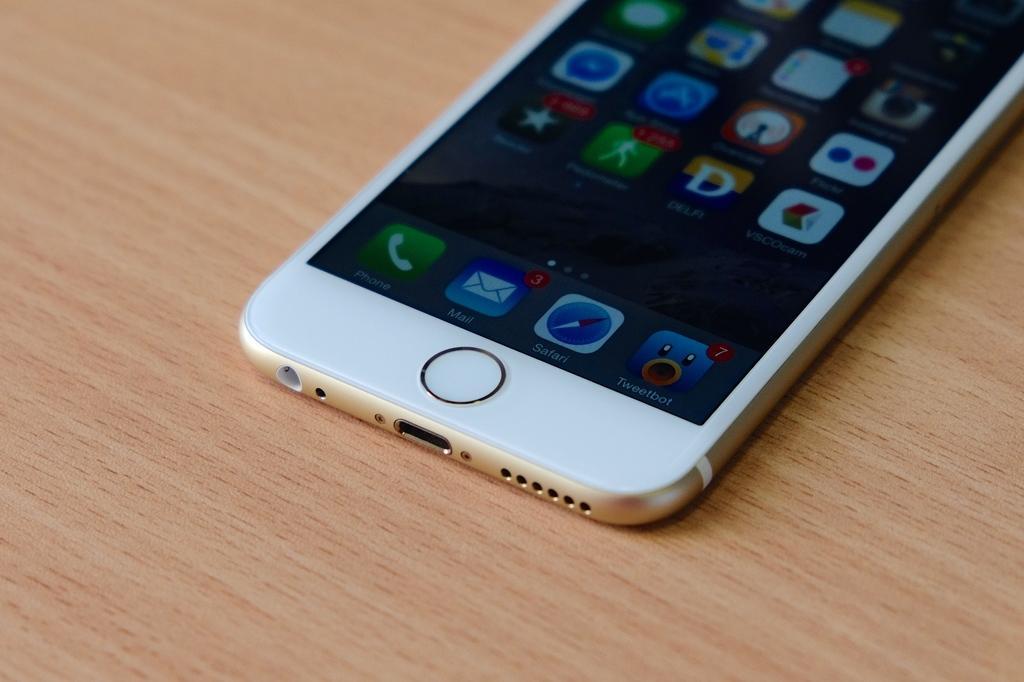Please provide a concise description of this image. In this picture I can see the brown color surface, on which there is a phone and on the screen I can see few applications and words written. 